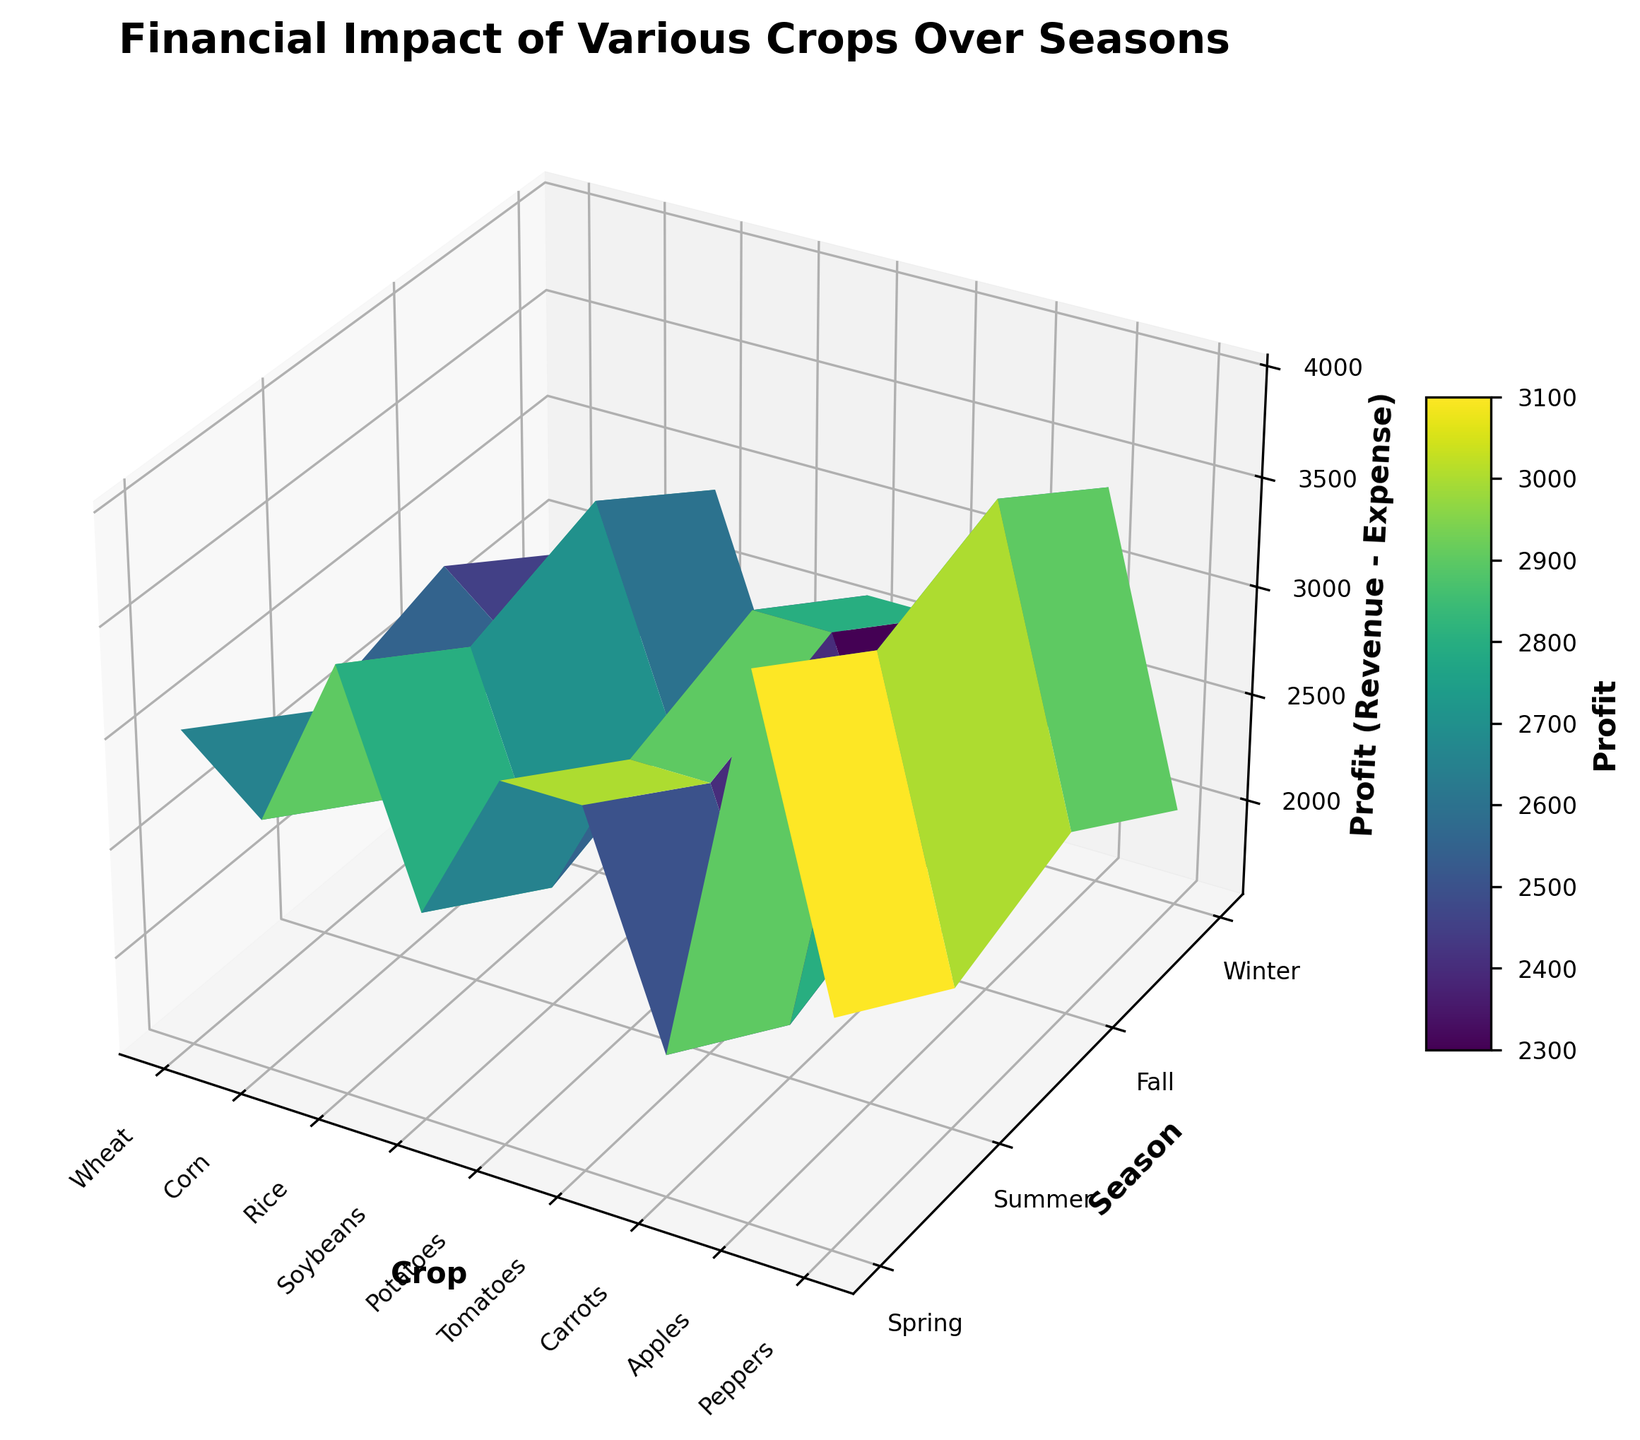Which crop has the highest profit in the Spring season? Look at the 'Spring' section across all crops and identify the highest peak. Apples show the highest value in this section.
Answer: Apples Which season generally provides the lowest profit for Soybeans? Observe the Soybeans row across all seasons. Winter shows the lowest peak indicating the lowest profit.
Answer: Winter Which crop consistently shows a profit higher than 3000 in all seasons? Check the profit values for each season across all crops. Apples consistently have profits higher than 3000 in all seasons.
Answer: Apples Compare the profit of Corn in the Summer and Fall seasons. Which season is more profitable? Check the height differences in the Corn row for Summer and Fall seasons. The peak is higher in Fall than in Summer for Corn.
Answer: Fall What's the average profit of Peppers over all seasons? Calculate the profits for Peppers in Spring, Summer, Fall, and Winter. Sum up these values and divide by 4.
Answer: 2400 Which crop has the lowest profit in the Winter season? Look at the 'Winter' section across all crops and identify the lowest point. Carrots show the lowest value in this section.
Answer: Carrots Is the profit for Wheat in Spring higher or lower than in Winter? Compare the height of the 'Spring' and 'Winter' peaks in the Wheat row. The peak in Spring is higher than in Winter.
Answer: Higher Between Potatoes and Tomatoes, which crop has a higher profit in the Summer season? Compare the heights of the 'Summer' peaks for Potatoes and Tomatoes. Potatoes have a higher peak.
Answer: Potatoes What is the difference in profit between Rice in Fall and Carrots in the same season? Calculate the heights of the 'Fall' peaks for Rice and Carrots, then find the difference.
Answer: 2500 